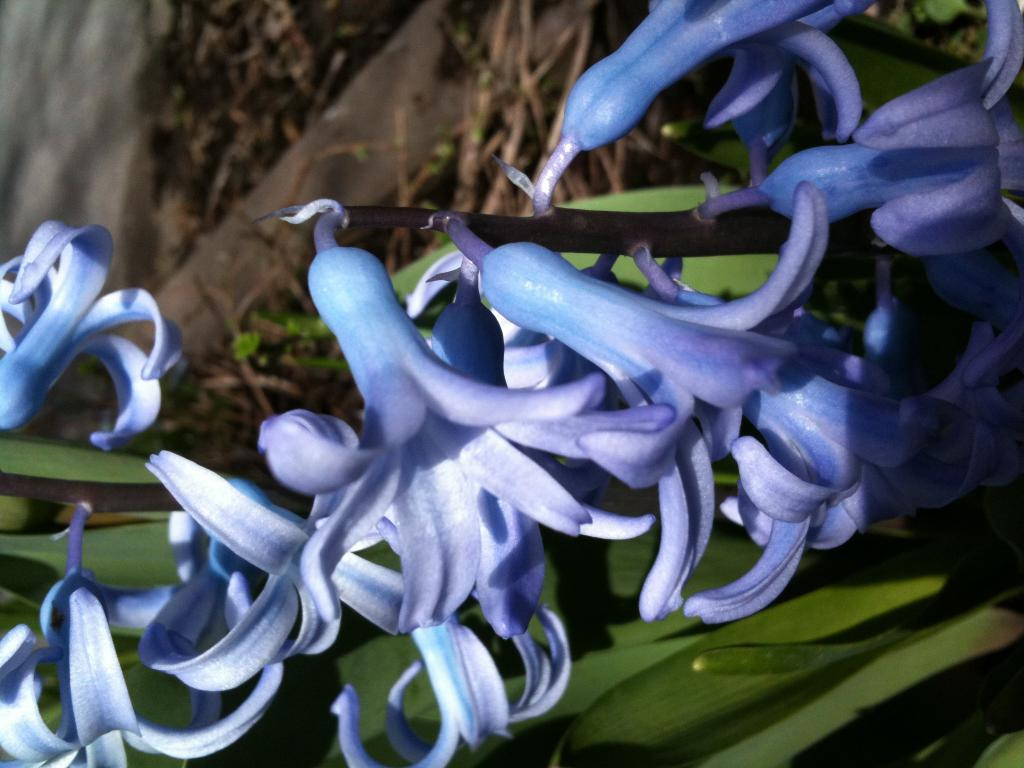What type of living organisms can be seen in the image? Plants can be seen in the image. What specific feature can be observed on the plants? The plants have flowers on them. What type of fog can be seen surrounding the dad and aunt in the image? There is no dad, aunt, or fog present in the image; it only features plants with flowers. 